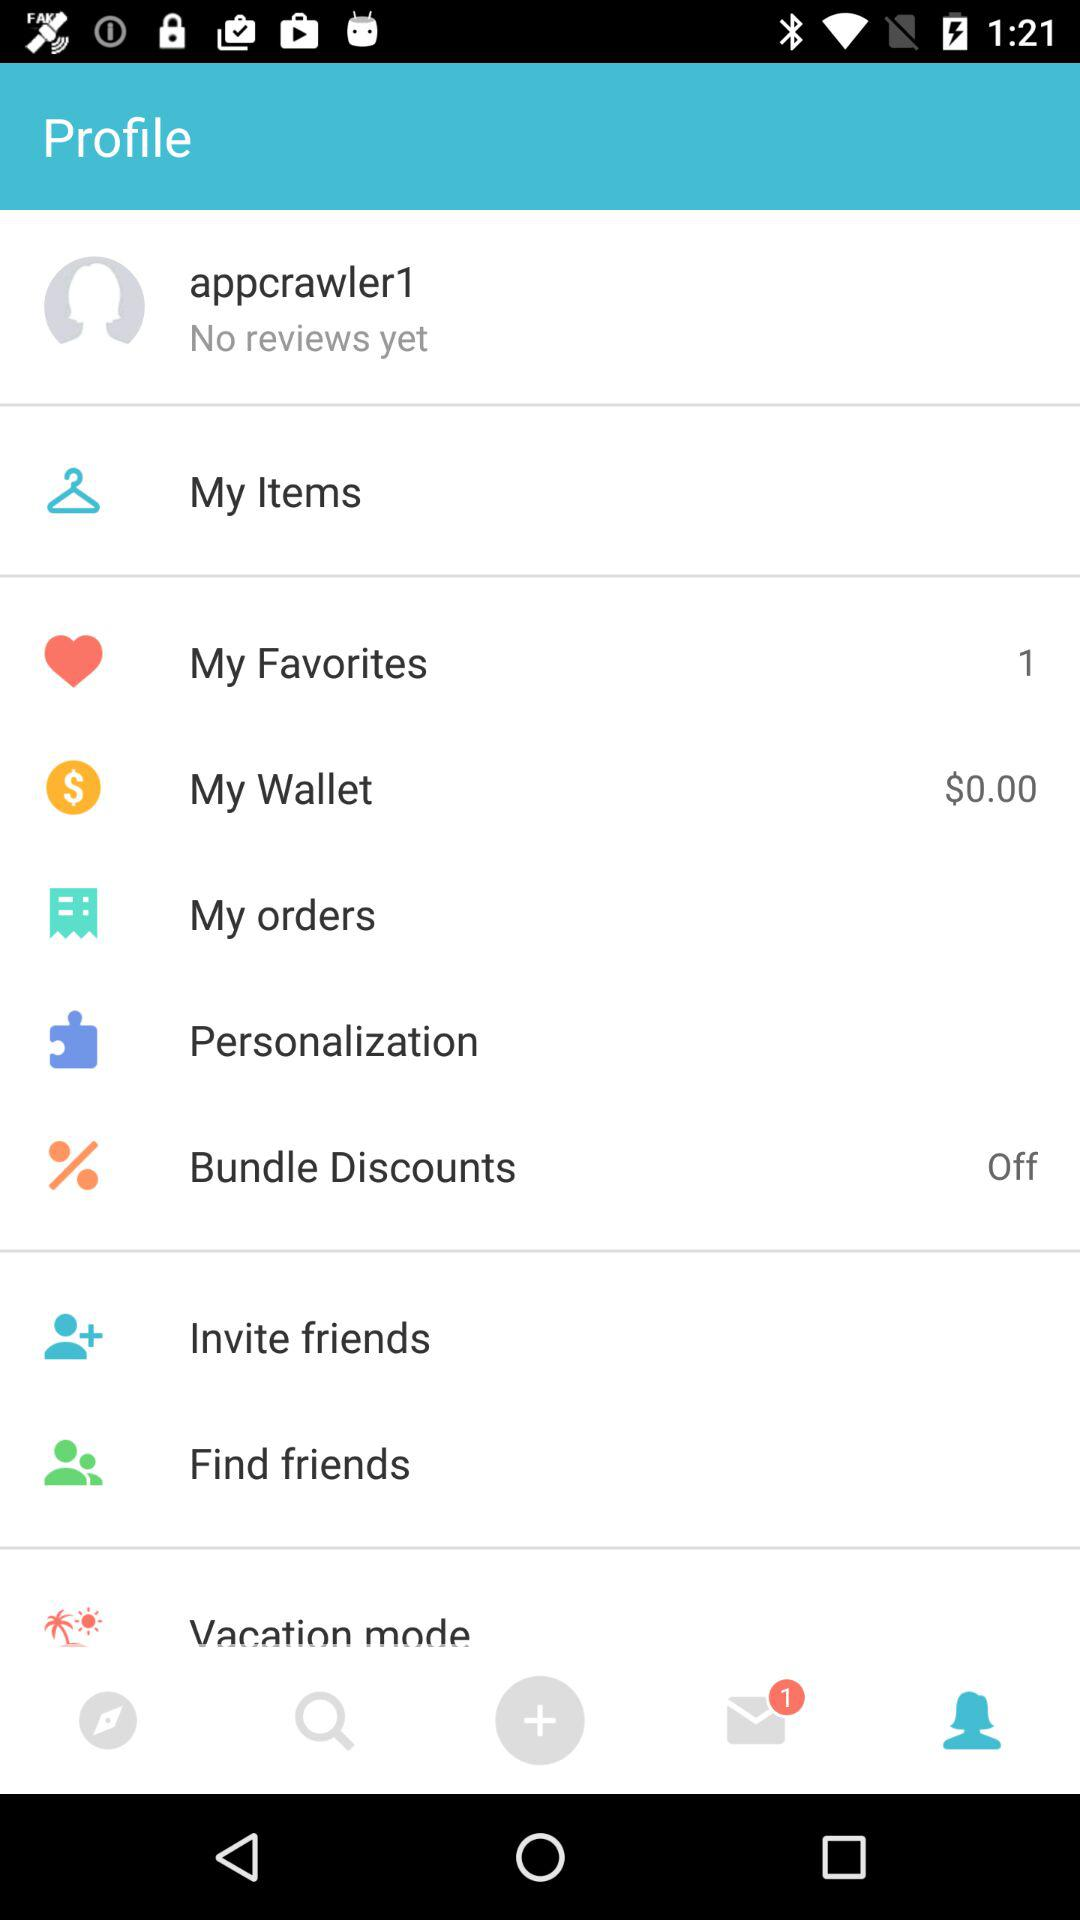What is the count of items in "My Favorites"? The count of items in "My Favorites" is 1. 